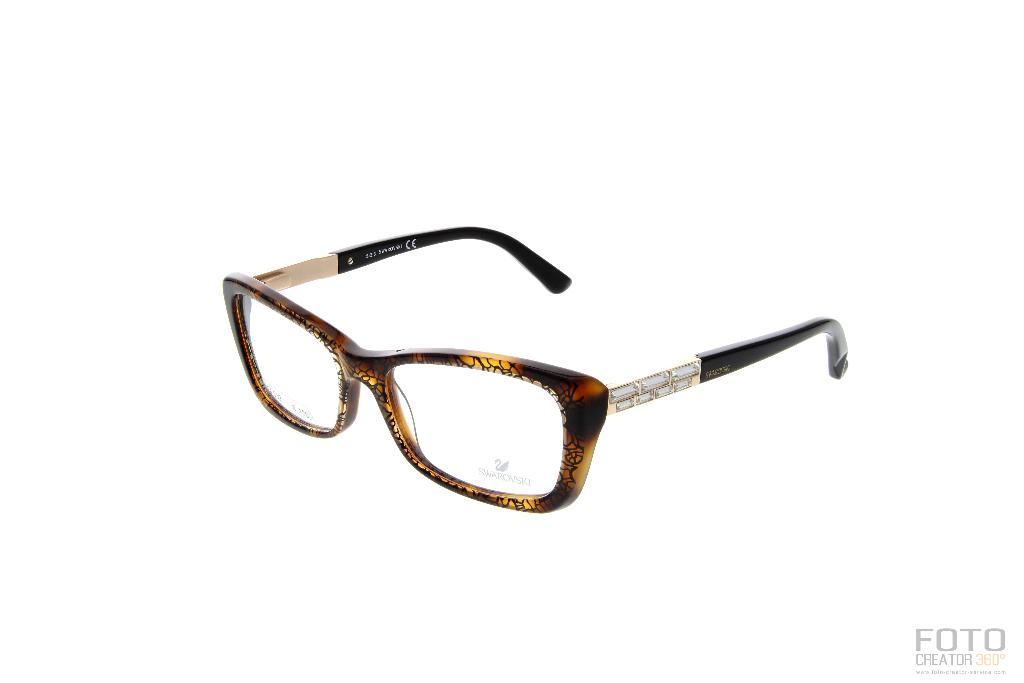What is the main subject of the image? There is a spectacle in the image. What color is the background of the image? The background of the image is white. What type of reward is being given to the person with the spectacle in the image? There is no reward being given in the image; it only features a spectacle and a white background. How many teeth can be seen in the image? There are no teeth visible in the image. 